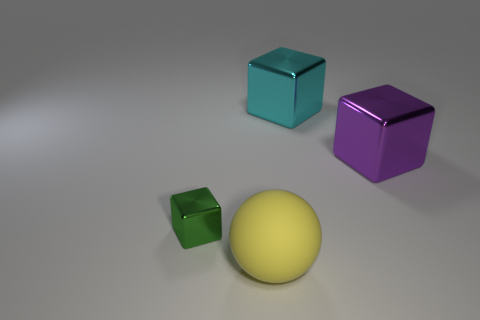There is a object in front of the cube that is on the left side of the shiny block that is behind the big purple shiny thing; what size is it?
Your answer should be compact. Large. How many things are metallic objects behind the small green metal thing or large objects?
Your answer should be compact. 3. How many green metallic objects are behind the large block to the right of the large cyan block?
Your response must be concise. 0. Is the number of purple objects to the left of the large yellow rubber thing greater than the number of metallic cubes?
Your answer should be very brief. No. What is the size of the thing that is both behind the big yellow rubber ball and in front of the purple cube?
Your response must be concise. Small. What is the shape of the metallic thing that is in front of the cyan cube and to the right of the small thing?
Ensure brevity in your answer.  Cube. There is a block in front of the object to the right of the big cyan thing; is there a thing that is behind it?
Your response must be concise. Yes. How many objects are shiny objects that are left of the big yellow sphere or shiny things that are left of the big yellow ball?
Keep it short and to the point. 1. Are the large thing that is behind the large purple cube and the yellow thing made of the same material?
Keep it short and to the point. No. The object that is on the right side of the tiny green object and to the left of the big cyan metal block is made of what material?
Ensure brevity in your answer.  Rubber. 